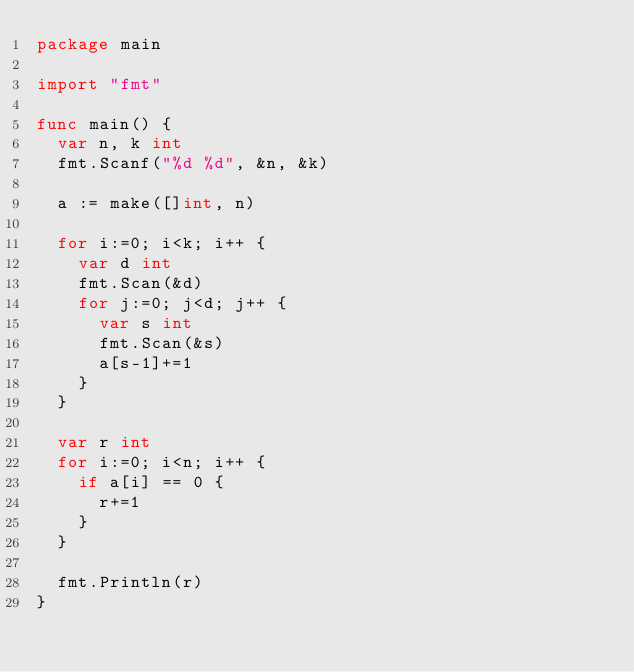Convert code to text. <code><loc_0><loc_0><loc_500><loc_500><_Go_>package main

import "fmt"

func main() {
  var n, k int
  fmt.Scanf("%d %d", &n, &k)
  
  a := make([]int, n)
  
  for i:=0; i<k; i++ {
    var d int
    fmt.Scan(&d)
    for j:=0; j<d; j++ {
      var s int
      fmt.Scan(&s)
      a[s-1]+=1
    }
  }
  
  var r int
  for i:=0; i<n; i++ {
    if a[i] == 0 {
      r+=1
    }
  }
  
  fmt.Println(r)
}</code> 